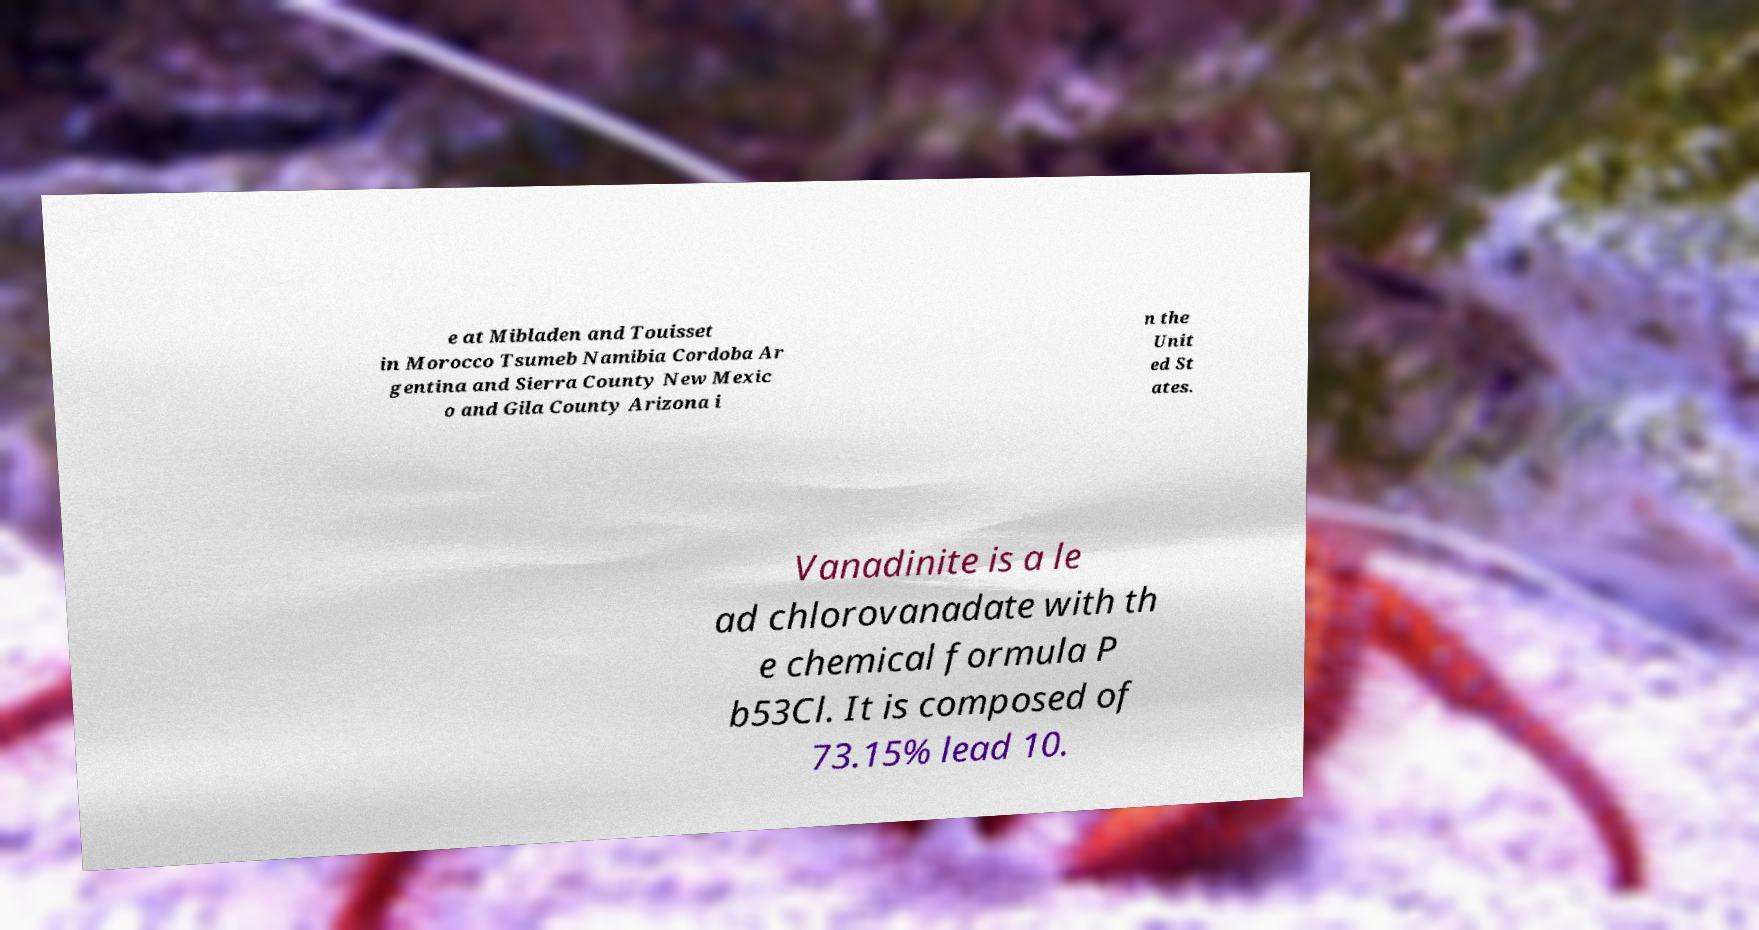There's text embedded in this image that I need extracted. Can you transcribe it verbatim? e at Mibladen and Touisset in Morocco Tsumeb Namibia Cordoba Ar gentina and Sierra County New Mexic o and Gila County Arizona i n the Unit ed St ates. Vanadinite is a le ad chlorovanadate with th e chemical formula P b53Cl. It is composed of 73.15% lead 10. 